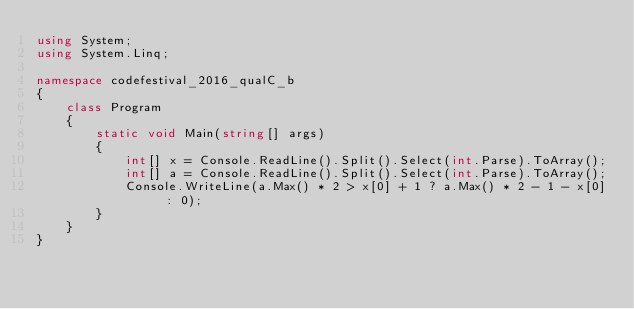Convert code to text. <code><loc_0><loc_0><loc_500><loc_500><_C#_>using System;
using System.Linq;

namespace codefestival_2016_qualC_b
{
    class Program
    {
        static void Main(string[] args)
        {
            int[] x = Console.ReadLine().Split().Select(int.Parse).ToArray();
            int[] a = Console.ReadLine().Split().Select(int.Parse).ToArray();
            Console.WriteLine(a.Max() * 2 > x[0] + 1 ? a.Max() * 2 - 1 - x[0] : 0);
        }
    }
}</code> 